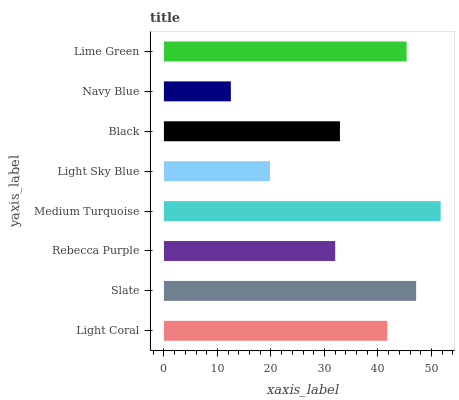Is Navy Blue the minimum?
Answer yes or no. Yes. Is Medium Turquoise the maximum?
Answer yes or no. Yes. Is Slate the minimum?
Answer yes or no. No. Is Slate the maximum?
Answer yes or no. No. Is Slate greater than Light Coral?
Answer yes or no. Yes. Is Light Coral less than Slate?
Answer yes or no. Yes. Is Light Coral greater than Slate?
Answer yes or no. No. Is Slate less than Light Coral?
Answer yes or no. No. Is Light Coral the high median?
Answer yes or no. Yes. Is Black the low median?
Answer yes or no. Yes. Is Navy Blue the high median?
Answer yes or no. No. Is Lime Green the low median?
Answer yes or no. No. 